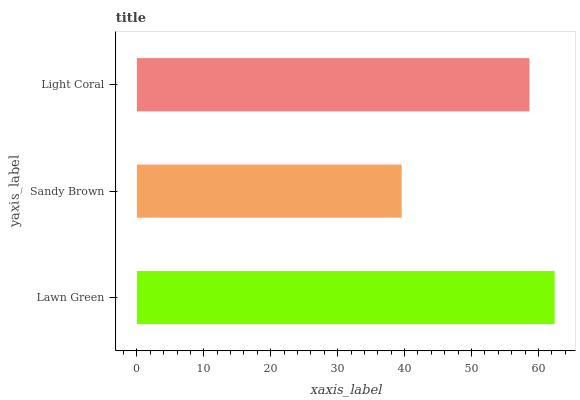Is Sandy Brown the minimum?
Answer yes or no. Yes. Is Lawn Green the maximum?
Answer yes or no. Yes. Is Light Coral the minimum?
Answer yes or no. No. Is Light Coral the maximum?
Answer yes or no. No. Is Light Coral greater than Sandy Brown?
Answer yes or no. Yes. Is Sandy Brown less than Light Coral?
Answer yes or no. Yes. Is Sandy Brown greater than Light Coral?
Answer yes or no. No. Is Light Coral less than Sandy Brown?
Answer yes or no. No. Is Light Coral the high median?
Answer yes or no. Yes. Is Light Coral the low median?
Answer yes or no. Yes. Is Sandy Brown the high median?
Answer yes or no. No. Is Lawn Green the low median?
Answer yes or no. No. 